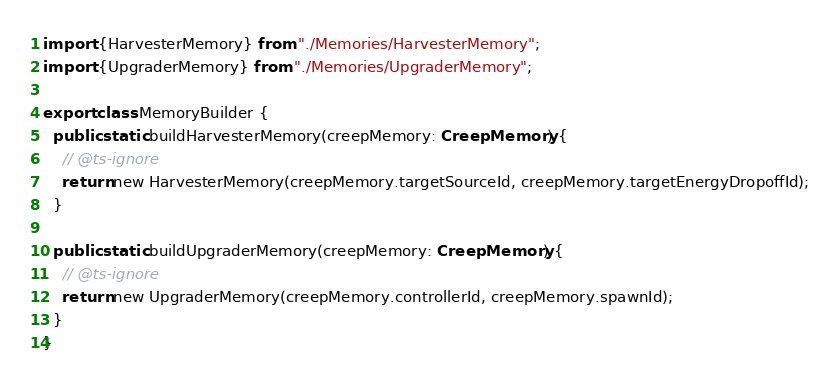<code> <loc_0><loc_0><loc_500><loc_500><_TypeScript_>import {HarvesterMemory} from "./Memories/HarvesterMemory";
import {UpgraderMemory} from "./Memories/UpgraderMemory";

export class MemoryBuilder {
  public static buildHarvesterMemory(creepMemory: CreepMemory) {
    // @ts-ignore
    return new HarvesterMemory(creepMemory.targetSourceId, creepMemory.targetEnergyDropoffId);
  }

  public static buildUpgraderMemory(creepMemory: CreepMemory) {
    // @ts-ignore
    return new UpgraderMemory(creepMemory.controllerId, creepMemory.spawnId);
  }
}
</code> 